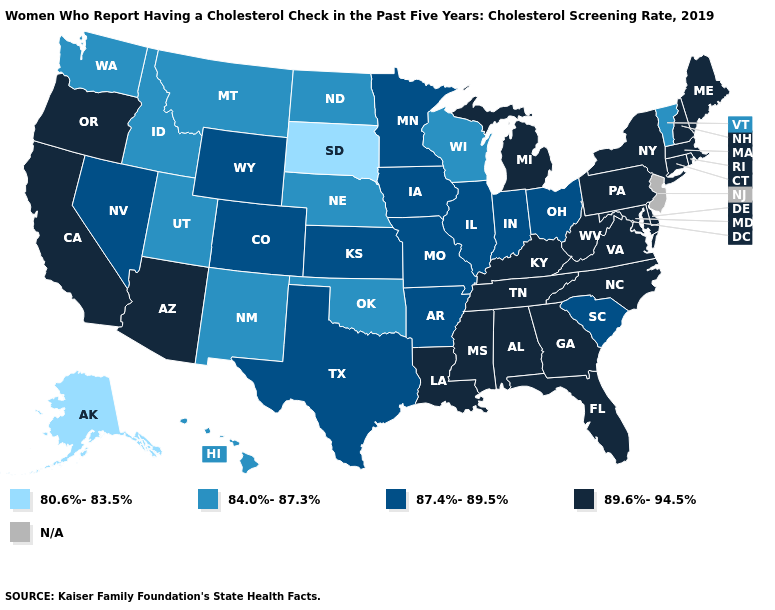Name the states that have a value in the range 89.6%-94.5%?
Give a very brief answer. Alabama, Arizona, California, Connecticut, Delaware, Florida, Georgia, Kentucky, Louisiana, Maine, Maryland, Massachusetts, Michigan, Mississippi, New Hampshire, New York, North Carolina, Oregon, Pennsylvania, Rhode Island, Tennessee, Virginia, West Virginia. Does Delaware have the highest value in the USA?
Write a very short answer. Yes. Among the states that border Washington , does Idaho have the highest value?
Be succinct. No. What is the value of Tennessee?
Concise answer only. 89.6%-94.5%. Is the legend a continuous bar?
Concise answer only. No. What is the lowest value in the West?
Answer briefly. 80.6%-83.5%. What is the value of Washington?
Concise answer only. 84.0%-87.3%. Name the states that have a value in the range 84.0%-87.3%?
Keep it brief. Hawaii, Idaho, Montana, Nebraska, New Mexico, North Dakota, Oklahoma, Utah, Vermont, Washington, Wisconsin. What is the value of Ohio?
Quick response, please. 87.4%-89.5%. What is the highest value in the USA?
Give a very brief answer. 89.6%-94.5%. What is the lowest value in the MidWest?
Answer briefly. 80.6%-83.5%. Name the states that have a value in the range 84.0%-87.3%?
Keep it brief. Hawaii, Idaho, Montana, Nebraska, New Mexico, North Dakota, Oklahoma, Utah, Vermont, Washington, Wisconsin. What is the highest value in the MidWest ?
Short answer required. 89.6%-94.5%. Which states have the lowest value in the West?
Concise answer only. Alaska. 